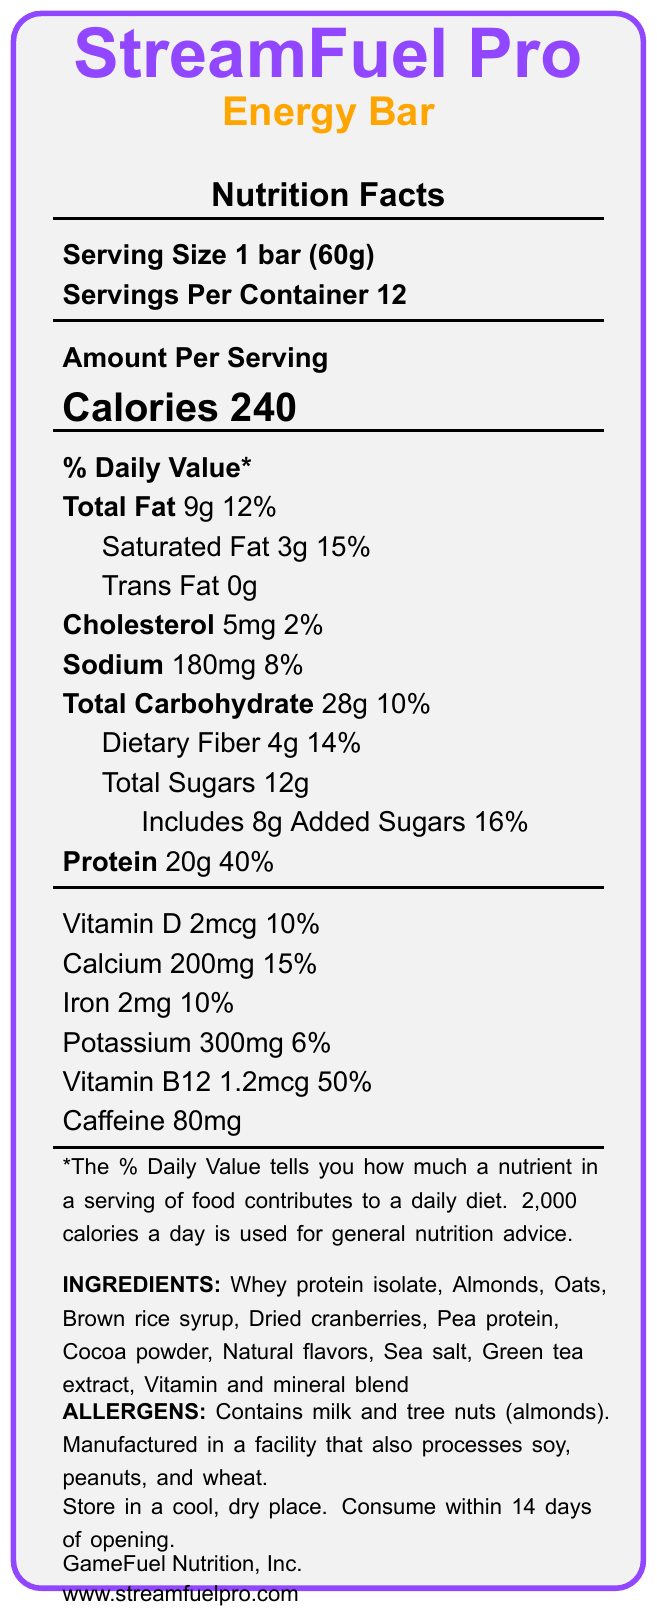what is the product name? The product name is displayed at the top of the document: "StreamFuel Pro Energy Bar".
Answer: StreamFuel Pro Energy Bar what is the serving size? The serving size is provided in the section titled "Nutrition Facts" under the "Serving Size" label: 1 bar (60g).
Answer: 1 bar (60g) how many calories are in one serving? The amount of calories per serving is prominently listed as "Calories 240".
Answer: 240 calories what is the daily value percentage of protein in one serving? The percentage daily value of protein per serving is listed under "Protein" as 40%.
Answer: 40% what are the first three ingredients listed? The ingredients are listed, and the first three are Whey protein isolate, Almonds, Oats.
Answer: Whey protein isolate, Almonds, Oats what is the amount of dietary fiber per serving? The document states under "Dietary Fiber" that there are 4g per serving.
Answer: 4g how much added sugars does the bar contain? The "Added Sugars" section shows it contains 8g of added sugars.
Answer: 8g which vitamin contributes the highest percentage to daily value? A. Vitamin D B. Calcium C. Iron D. Vitamin B12 Vitamin B12 has a daily value contribution of 50%, which is the highest listed in the document.
Answer: D what is the total amount of sodium per serving? The amount of sodium per serving is clearly displayed under "Sodium" as 180mg.
Answer: 180mg which ingredient provides the caffeine content? A. Cocoa powder B. Green tea extract C. Pea protein D. Natural flavors Green tea extract is known for its caffeine content, and it is listed among the ingredients.
Answer: B does the product contain any allergens? The allergens section confirms that the product contains milk and tree nuts (almonds).
Answer: Yes how long can you consume the product after opening? The storage instructions state that the product should be consumed within 14 days of opening.
Answer: 14 days what are the marketing claims of this product? The document lists multiple marketing claims which can be found under the "Marketing Claims" section.
Answer: 20g of high-quality protein for muscle recovery, Sustained energy release for long streaming sessions, Added B12 for improved focus and alertness, No artificial sweeteners or preservatives, Gluten-free, Non-GMO ingredients what is the manufacturer's name? The name of the manufacturer is given as GameFuel Nutrition, Inc.
Answer: GameFuel Nutrition, Inc. what is the main idea of the document? The document is structured to present a comprehensive overview of the StreamFuel Pro Energy Bar's nutritional content and benefits, aimed at streamers for long periods of sustained energy.
Answer: The document provides detailed nutritional information about the StreamFuel Pro Energy Bar, highlighting its high protein content, energy-sustaining properties, added vitamins, and allergen information. It also lists storage guidelines and marketing claims promoting the product's benefits for streamers. how much iron does one serving contain? The amount of iron per serving is listed as 2mg under the "Iron" section.
Answer: 2mg can we determine if the product is vegan? The document does not provide sufficient information regarding whether the product is vegan or not. Neither the ingredients nor the marketing claims specify this information.
Answer: Cannot be determined 